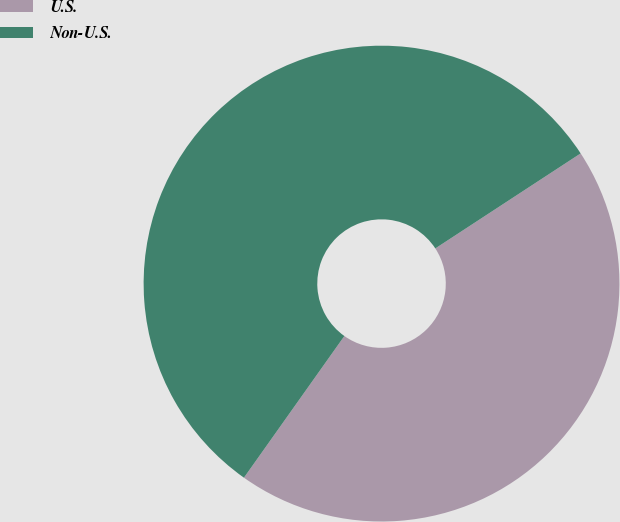Convert chart. <chart><loc_0><loc_0><loc_500><loc_500><pie_chart><fcel>U.S.<fcel>Non-U.S.<nl><fcel>44.03%<fcel>55.97%<nl></chart> 